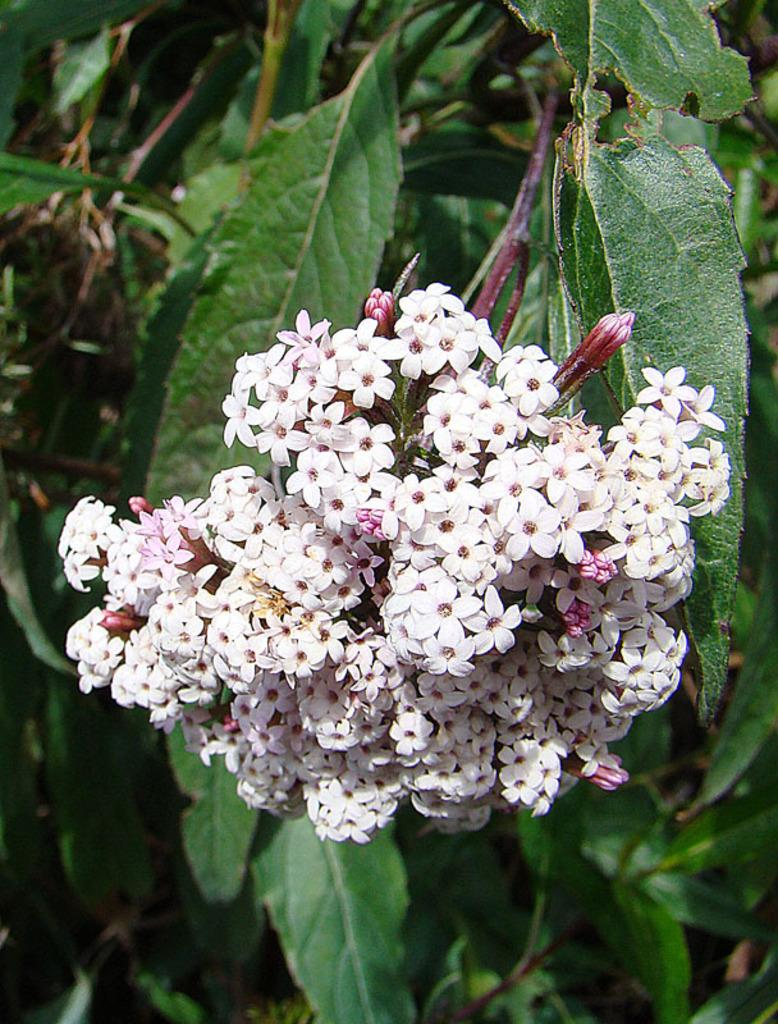What is present in the image? There is a plant in the image. What can be observed about the flowers on the plant? The flowers on the plant have a white color. What type of fork is used to adjust the plant's growth in the image? There is no fork present in the image, and the plant's growth is not being adjusted. 